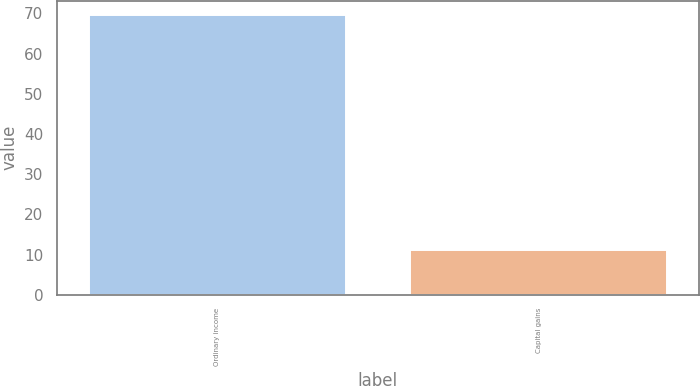<chart> <loc_0><loc_0><loc_500><loc_500><bar_chart><fcel>Ordinary income<fcel>Capital gains<nl><fcel>69.7<fcel>11.2<nl></chart> 